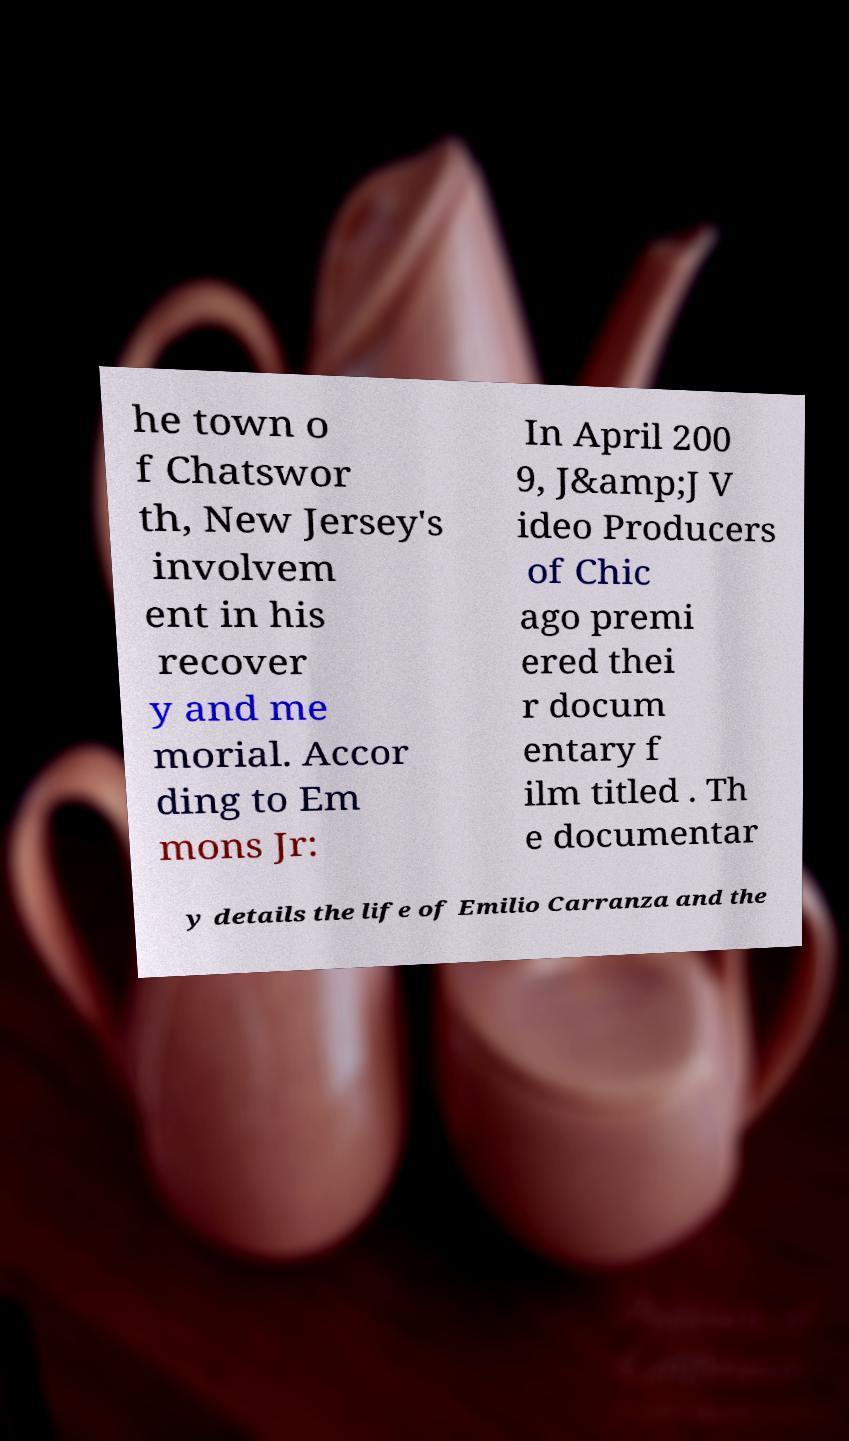Please identify and transcribe the text found in this image. he town o f Chatswor th, New Jersey's involvem ent in his recover y and me morial. Accor ding to Em mons Jr: In April 200 9, J&amp;J V ideo Producers of Chic ago premi ered thei r docum entary f ilm titled . Th e documentar y details the life of Emilio Carranza and the 